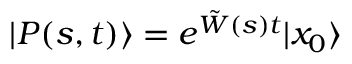<formula> <loc_0><loc_0><loc_500><loc_500>| P ( s , t ) \rangle = e ^ { \tilde { W } ( s ) t } | x _ { 0 } \rangle</formula> 